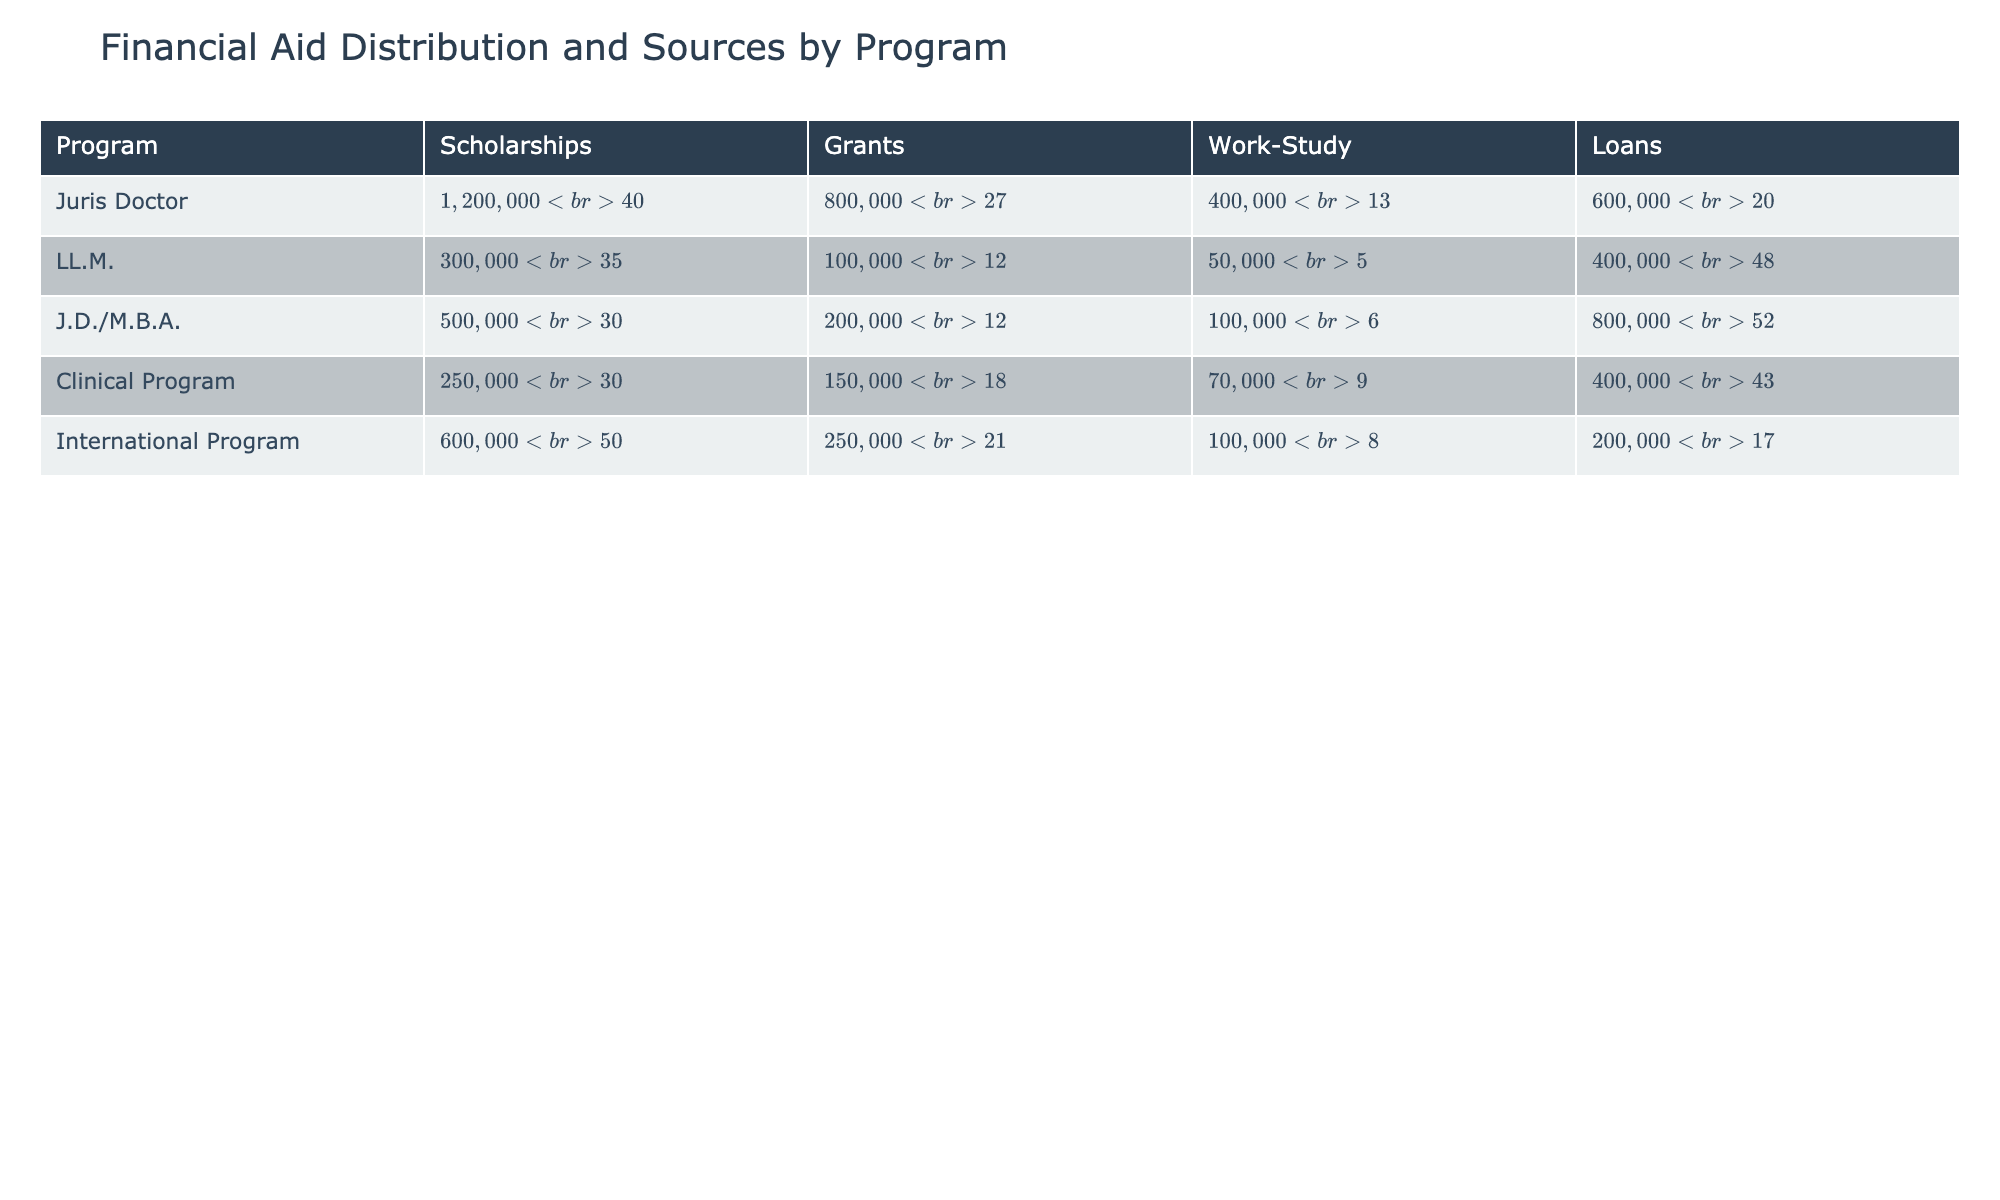What is the total aid distributed for the Juris Doctor program? The Juris Doctor program has four sources of aid: Scholarships ($1,200,000), Grants ($800,000), Work-Study ($400,000), and Loans ($600,000). Adding these amounts together gives a total of $1,200,000 + $800,000 + $400,000 + $600,000 = $3,000,000.
Answer: $3,000,000 Which program received the highest total aid in Scholarships? Looking at the Scholarships row for each program, the Juris Doctor received $1,200,000, the International Program received $600,000, the J.D./M.B.A received $500,000, the Clinical Program received $250,000, and the LL.M. received $300,000. The highest among these is $1,200,000 for the Juris Doctor program.
Answer: Juris Doctor What percentage of total aid for the LL.M. program comes from Loans? The total aid for the LL.M. program is $300,000 (Scholarships) + $100,000 (Grants) + $50,000 (Work-Study) + $400,000 (Loans) = $850,000. The Loans amount to $400,000. The percentage of Loans is calculated as ($400,000 / $850,000) * 100 = 47.06%, or approximately 48%.
Answer: 48% Is it true that the J.D./M.B.A. program received priority awards for all sources of aid? Reviewing the Priority Awarded column for the J.D./M.B.A. program, only the Scholarships and Loans received priority, while Grants and Work-Study did not. Therefore, it is false that all sources received priority awards.
Answer: No What is the average award amount for the Loans across all programs? The average award amount for Loans across the four programs is calculated as follows: Juris Doctor ($15,000) + LL.M. ($40,000) + J.D./M.B.A. ($40,000) + Clinical Program ($40,000) + International Program ($40,000) adds up to $15,000 + $40,000 + $40,000 + $40,000 + $40,000 = $175,000. Dividing by the number of programs (5) gives an average of $175,000 / 5 = $35,000.
Answer: $35,000 Which financial aid source has the lowest total aid distribution for the Clinical Program? Looking through the various sources of aid for the Clinical Program: Scholarships $250,000, Grants $150,000, Work-Study $70,000, and Loans $400,000. The source with the lowest total aid distribution is Work-Study at $70,000.
Answer: Work-Study Which program has the highest average award amount for Scholarships? The average award amount for Scholarships can be observed directly from the table: Juris Doctor has an average of $20,000, LL.M. has $25,000, J.D./M.B.A. also has $25,000, Clinical Program has $20,000, and International Program has $30,000. Therefore, the International Program has the highest average award amount for Scholarships.
Answer: International Program What is the total number of recipients for each program? By adding up the number of recipients from all sources for each program: Juris Doctor (60 + 50 + 40 + 40 = 190), LL.M. (12 + 5 + 5 + 10 = 32), J.D./M.B.A. (20 + 10 + 10 + 20 = 70), Clinical Program (12 + 10 + 10 + 10 = 42), International Program (20 + 10 + 10 + 5 = 55). Thus, the totals are: Juris Doctor 190, LL.M. 32, J.D./M.B.A. 70, Clinical Program 42, and International Program 55.
Answer: Juris Doctor: 190, LL.M.: 32, J.D./M.B.A.: 70, Clinical Program: 42, International Program: 55 What percentage of the total aid for the J.D./M.B.A. program is made up of Grants? The total aid for the J.D./M.B.A. program is $500,000 (Scholarships) + $200,000 (Grants) + $100,000 (Work-Study) + $800,000 (Loans) = $1,600,000. The Grants amount to $200,000. The percentage is calculated as ($200,000 / $1,600,000) * 100 = 12.5%.
Answer: 12.5% If we combine all sources of work-study aid, what is the total amount distributed? The Work-Study amounts are Juris Doctor ($400,000), LL.M. ($50,000), J.D./M.B.A. ($100,000), Clinical Program ($70,000), and International Program ($100,000). Adding these together gives $400,000 + $50,000 + $100,000 + $70,000 + $100,000 = $720,000.
Answer: $720,000 